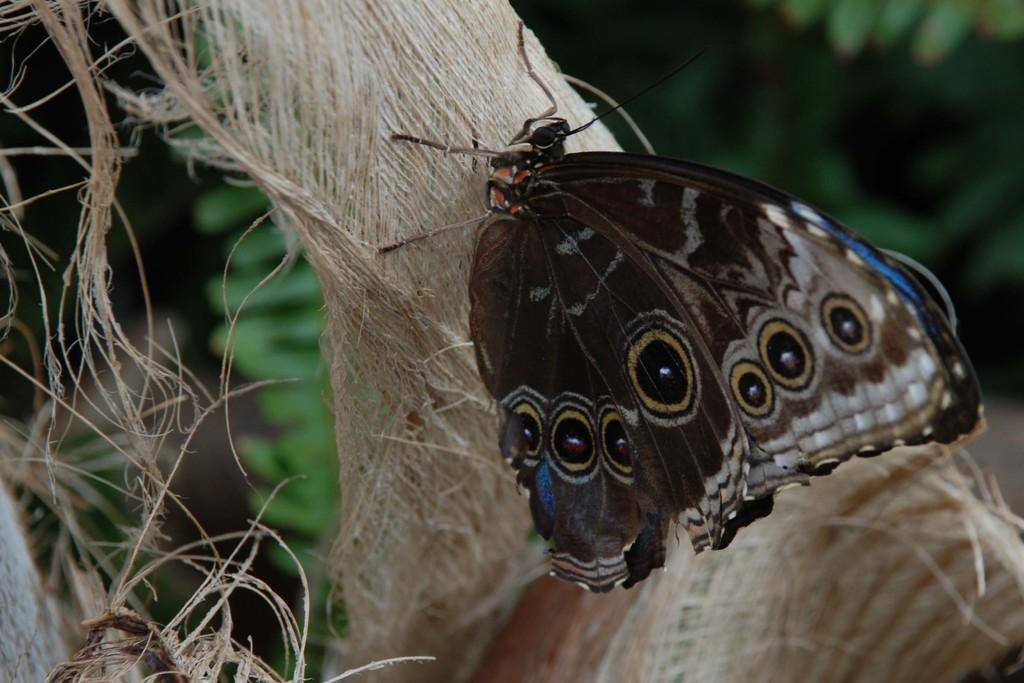What is the main subject of the image? There is a butterfly in the image. What can be seen in the background of the image? There are leaves in the background of the image. How would you describe the appearance of the background? The background of the image appears blurry. How many legs does the glass have in the image? There is no glass present in the image, so it is not possible to determine the number of legs it might have. 